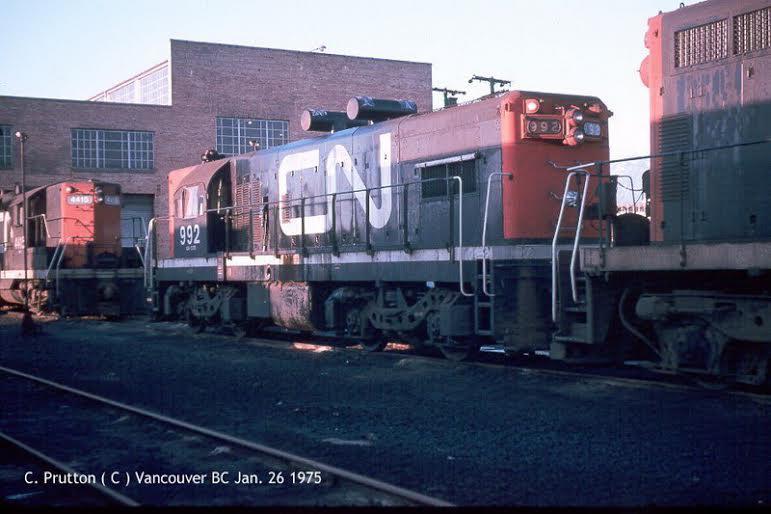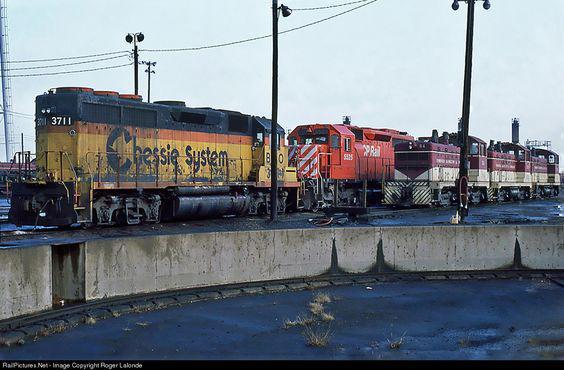The first image is the image on the left, the second image is the image on the right. For the images shown, is this caption "One train car is mostly orange, with diagonal stripes at it's nose." true? Answer yes or no. Yes. The first image is the image on the left, the second image is the image on the right. Examine the images to the left and right. Is the description "The right image includes at least one element with a pattern of bold diagonal lines near a red-orange train car." accurate? Answer yes or no. Yes. 